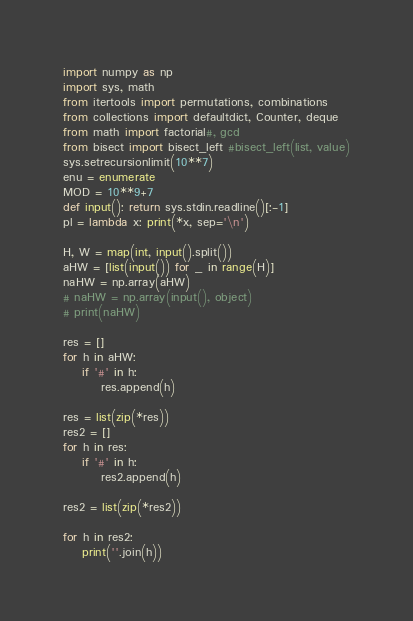<code> <loc_0><loc_0><loc_500><loc_500><_Python_>import numpy as np
import sys, math
from itertools import permutations, combinations
from collections import defaultdict, Counter, deque
from math import factorial#, gcd
from bisect import bisect_left #bisect_left(list, value)
sys.setrecursionlimit(10**7)
enu = enumerate
MOD = 10**9+7
def input(): return sys.stdin.readline()[:-1]
pl = lambda x: print(*x, sep='\n')

H, W = map(int, input().split())
aHW = [list(input()) for _ in range(H)]
naHW = np.array(aHW)
# naHW = np.array(input(), object)
# print(naHW)

res = []
for h in aHW:
    if '#' in h:
        res.append(h)

res = list(zip(*res))
res2 = []
for h in res:
    if '#' in h:
        res2.append(h)

res2 = list(zip(*res2))

for h in res2:
    print(''.join(h))</code> 